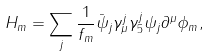<formula> <loc_0><loc_0><loc_500><loc_500>H _ { m } = \sum _ { j } \frac { 1 } { f _ { m } } \bar { \psi } _ { j } \gamma ^ { j } _ { \mu } \gamma ^ { j } _ { 5 } \psi _ { j } \partial ^ { \mu } \phi _ { m } ,</formula> 